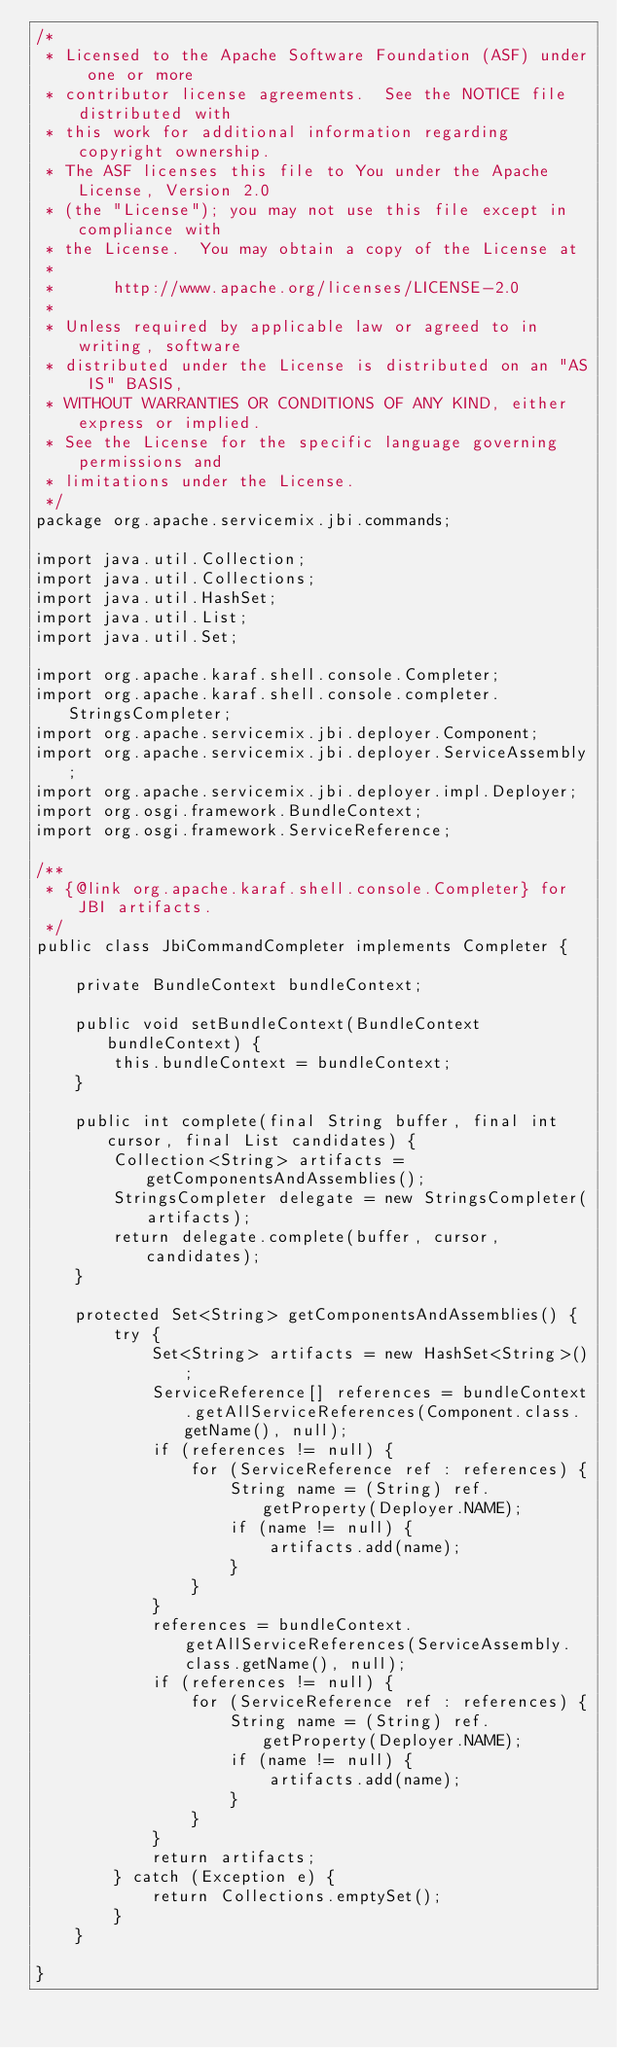<code> <loc_0><loc_0><loc_500><loc_500><_Java_>/*
 * Licensed to the Apache Software Foundation (ASF) under one or more
 * contributor license agreements.  See the NOTICE file distributed with
 * this work for additional information regarding copyright ownership.
 * The ASF licenses this file to You under the Apache License, Version 2.0
 * (the "License"); you may not use this file except in compliance with
 * the License.  You may obtain a copy of the License at
 *
 *      http://www.apache.org/licenses/LICENSE-2.0
 *
 * Unless required by applicable law or agreed to in writing, software
 * distributed under the License is distributed on an "AS IS" BASIS,
 * WITHOUT WARRANTIES OR CONDITIONS OF ANY KIND, either express or implied.
 * See the License for the specific language governing permissions and
 * limitations under the License.
 */
package org.apache.servicemix.jbi.commands;

import java.util.Collection;
import java.util.Collections;
import java.util.HashSet;
import java.util.List;
import java.util.Set;

import org.apache.karaf.shell.console.Completer;
import org.apache.karaf.shell.console.completer.StringsCompleter;
import org.apache.servicemix.jbi.deployer.Component;
import org.apache.servicemix.jbi.deployer.ServiceAssembly;
import org.apache.servicemix.jbi.deployer.impl.Deployer;
import org.osgi.framework.BundleContext;
import org.osgi.framework.ServiceReference;

/**
 * {@link org.apache.karaf.shell.console.Completer} for JBI artifacts.
 */
public class JbiCommandCompleter implements Completer {

    private BundleContext bundleContext;

    public void setBundleContext(BundleContext bundleContext) {
        this.bundleContext = bundleContext;
    }

    public int complete(final String buffer, final int cursor, final List candidates) {
        Collection<String> artifacts = getComponentsAndAssemblies();
        StringsCompleter delegate = new StringsCompleter(artifacts);
        return delegate.complete(buffer, cursor, candidates);
    }

    protected Set<String> getComponentsAndAssemblies() {
        try {
            Set<String> artifacts = new HashSet<String>();
            ServiceReference[] references = bundleContext.getAllServiceReferences(Component.class.getName(), null);
            if (references != null) {
                for (ServiceReference ref : references) {
                    String name = (String) ref.getProperty(Deployer.NAME);
                    if (name != null) {
                        artifacts.add(name);
                    }
                }
            }
            references = bundleContext.getAllServiceReferences(ServiceAssembly.class.getName(), null);
            if (references != null) {
                for (ServiceReference ref : references) {
                    String name = (String) ref.getProperty(Deployer.NAME);
                    if (name != null) {
                        artifacts.add(name);
                    }
                }
            }
            return artifacts;
        } catch (Exception e) {
            return Collections.emptySet();
        }
    }

}
</code> 